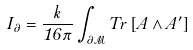<formula> <loc_0><loc_0><loc_500><loc_500>I _ { \partial } = \frac { k } { 1 6 \pi } \int _ { \partial \mathcal { M } } T r \left [ A \wedge A ^ { \prime } \right ]</formula> 